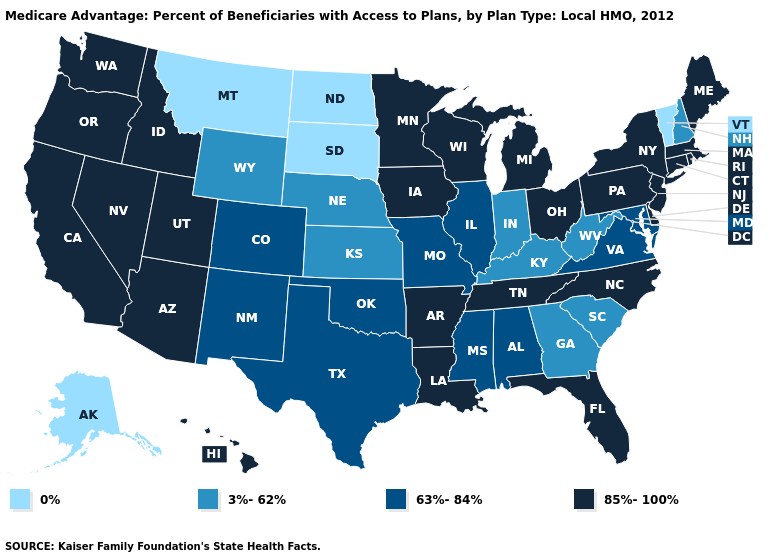Which states have the lowest value in the USA?
Give a very brief answer. Alaska, Montana, North Dakota, South Dakota, Vermont. What is the value of West Virginia?
Write a very short answer. 3%-62%. Which states hav the highest value in the South?
Keep it brief. Arkansas, Delaware, Florida, Louisiana, North Carolina, Tennessee. What is the highest value in the MidWest ?
Concise answer only. 85%-100%. How many symbols are there in the legend?
Quick response, please. 4. Among the states that border New York , does Connecticut have the lowest value?
Short answer required. No. Among the states that border Illinois , does Iowa have the highest value?
Quick response, please. Yes. What is the highest value in the USA?
Answer briefly. 85%-100%. Among the states that border North Carolina , which have the lowest value?
Give a very brief answer. Georgia, South Carolina. What is the value of Kansas?
Answer briefly. 3%-62%. What is the value of Maryland?
Concise answer only. 63%-84%. What is the highest value in the USA?
Keep it brief. 85%-100%. How many symbols are there in the legend?
Answer briefly. 4. Does Connecticut have the same value as Alabama?
Write a very short answer. No. Name the states that have a value in the range 63%-84%?
Be succinct. Alabama, Colorado, Illinois, Maryland, Missouri, Mississippi, New Mexico, Oklahoma, Texas, Virginia. 